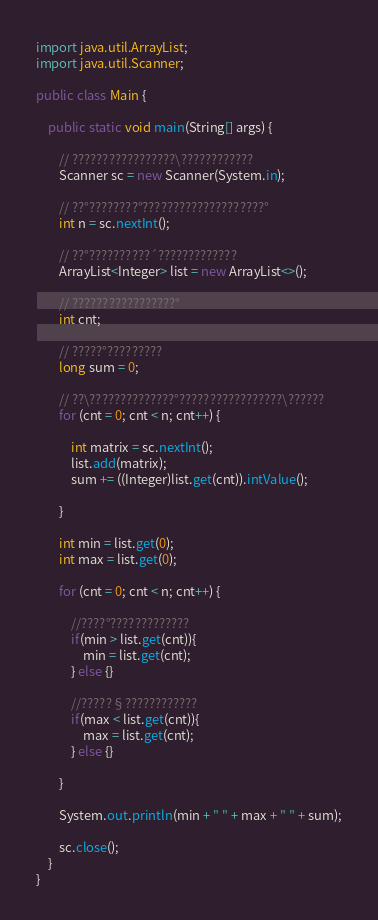Convert code to text. <code><loc_0><loc_0><loc_500><loc_500><_Java_>import java.util.ArrayList;
import java.util.Scanner;

public class Main {

	public static void main(String[] args) {

		// ?????????????????\????????????
		Scanner sc = new Scanner(System.in);

		// ??°????????°????????????????????°
		int n = sc.nextInt();

		// ??°??????????´?????????????
		ArrayList<Integer> list = new ArrayList<>();

		// ?????????????????°
		int cnt;

		// ?????°?????????
		long sum = 0;

		// ??\??????????????°?????????????????\??????
		for (cnt = 0; cnt < n; cnt++) {

			int matrix = sc.nextInt();
			list.add(matrix);
			sum += ((Integer)list.get(cnt)).intValue();

		}

		int min = list.get(0);
		int max = list.get(0);

		for (cnt = 0; cnt < n; cnt++) {

			//????°?????????????
			if(min > list.get(cnt)){
				min = list.get(cnt);
			} else {}

			//?????§????????????
			if(max < list.get(cnt)){
				max = list.get(cnt);
			} else {}

	    }

		System.out.println(min + " " + max + " " + sum);

		sc.close();
	}
}</code> 